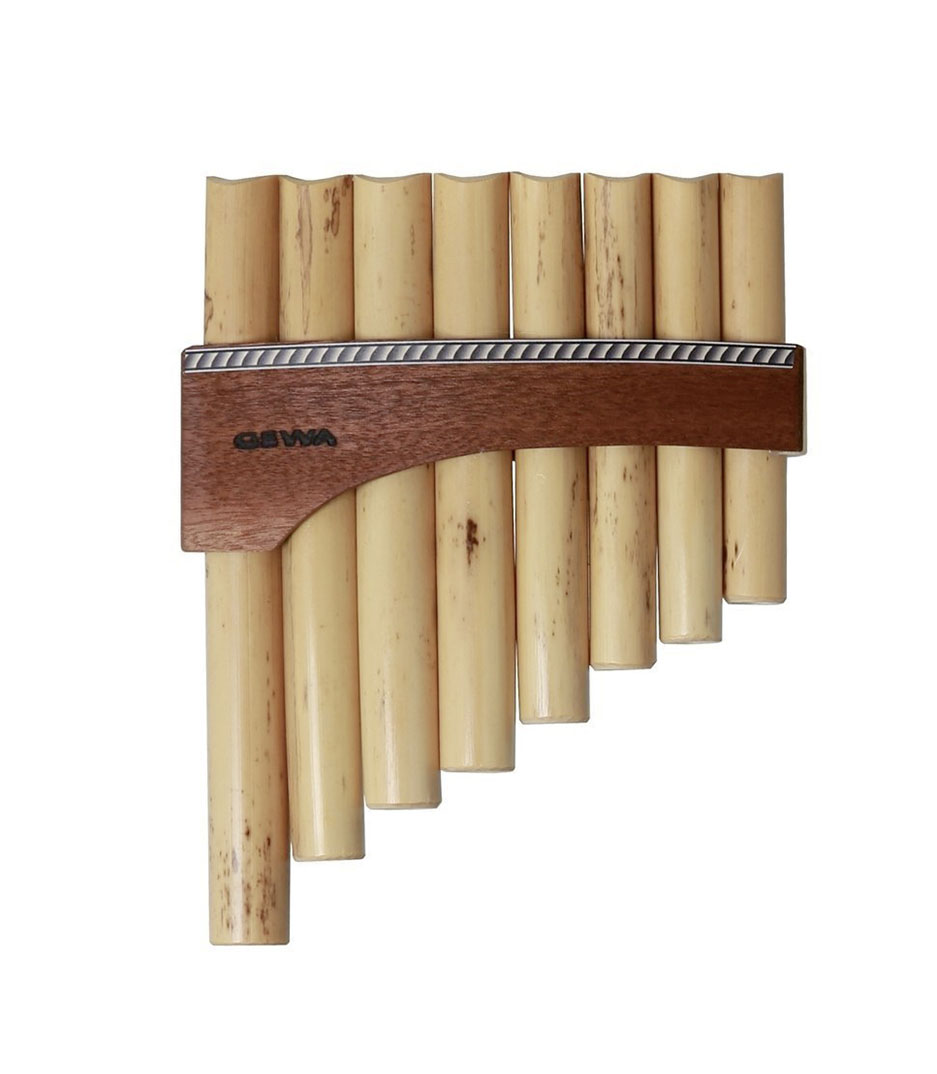What materials are typically used to make pan flutes, and what are the benefits of these materials? Pan flutes are traditionally made from natural materials such as bamboo, wood, or reed. These materials are favored for their availability, workability, and the resonant qualities they confer to the instrument. Bamboo, for instance, is highly sustainable and produces a warm, clear sound, making it a preferred choice. Using these natural materials not only enhances the acoustic properties but also links the instrument to its cultural roots, enhancing its authenticity and traditional appeal. 